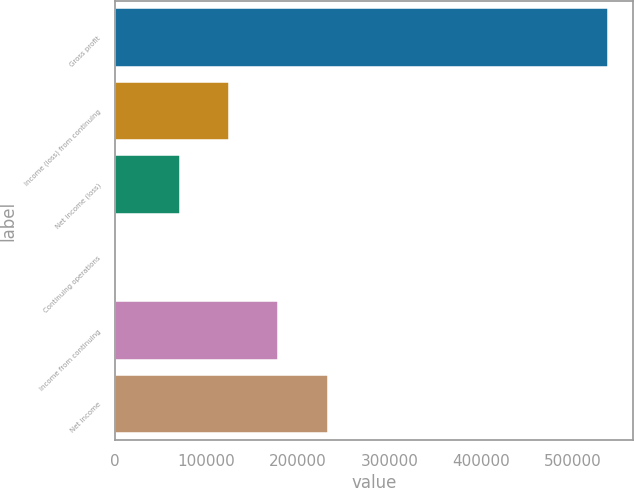<chart> <loc_0><loc_0><loc_500><loc_500><bar_chart><fcel>Gross profit<fcel>Income (loss) from continuing<fcel>Net income (loss)<fcel>Continuing operations<fcel>Income from continuing<fcel>Net income<nl><fcel>539531<fcel>124570<fcel>70617<fcel>0.2<fcel>178523<fcel>232476<nl></chart> 